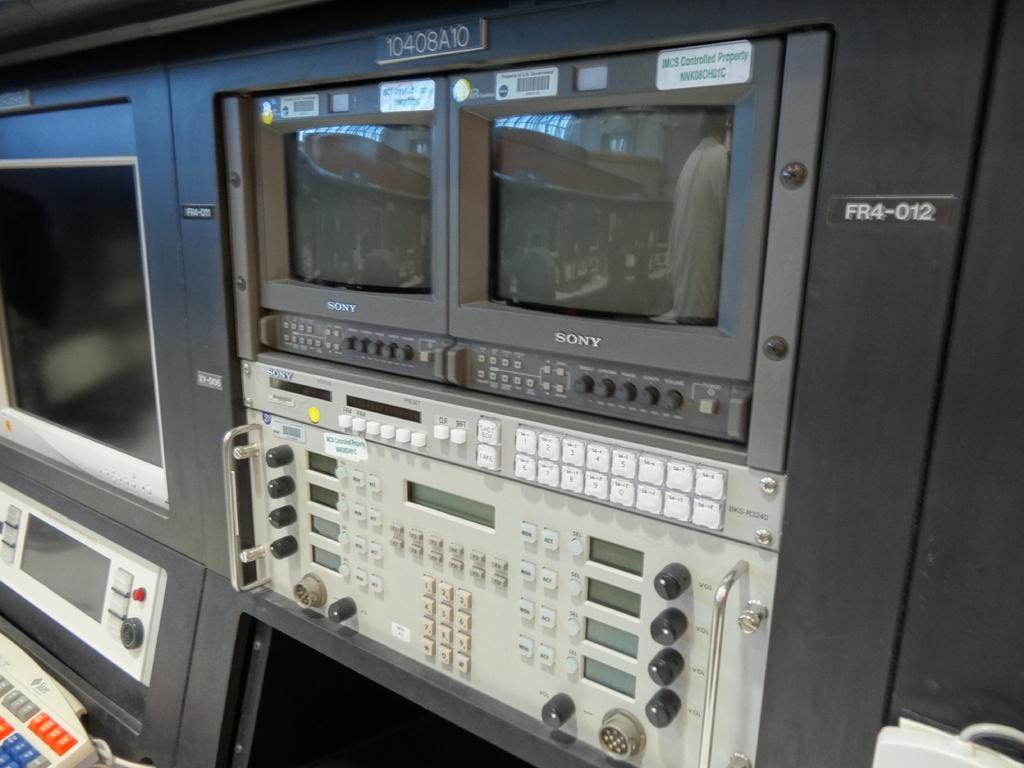<image>
Share a concise interpretation of the image provided. the word Sony is on the front of a large machine 